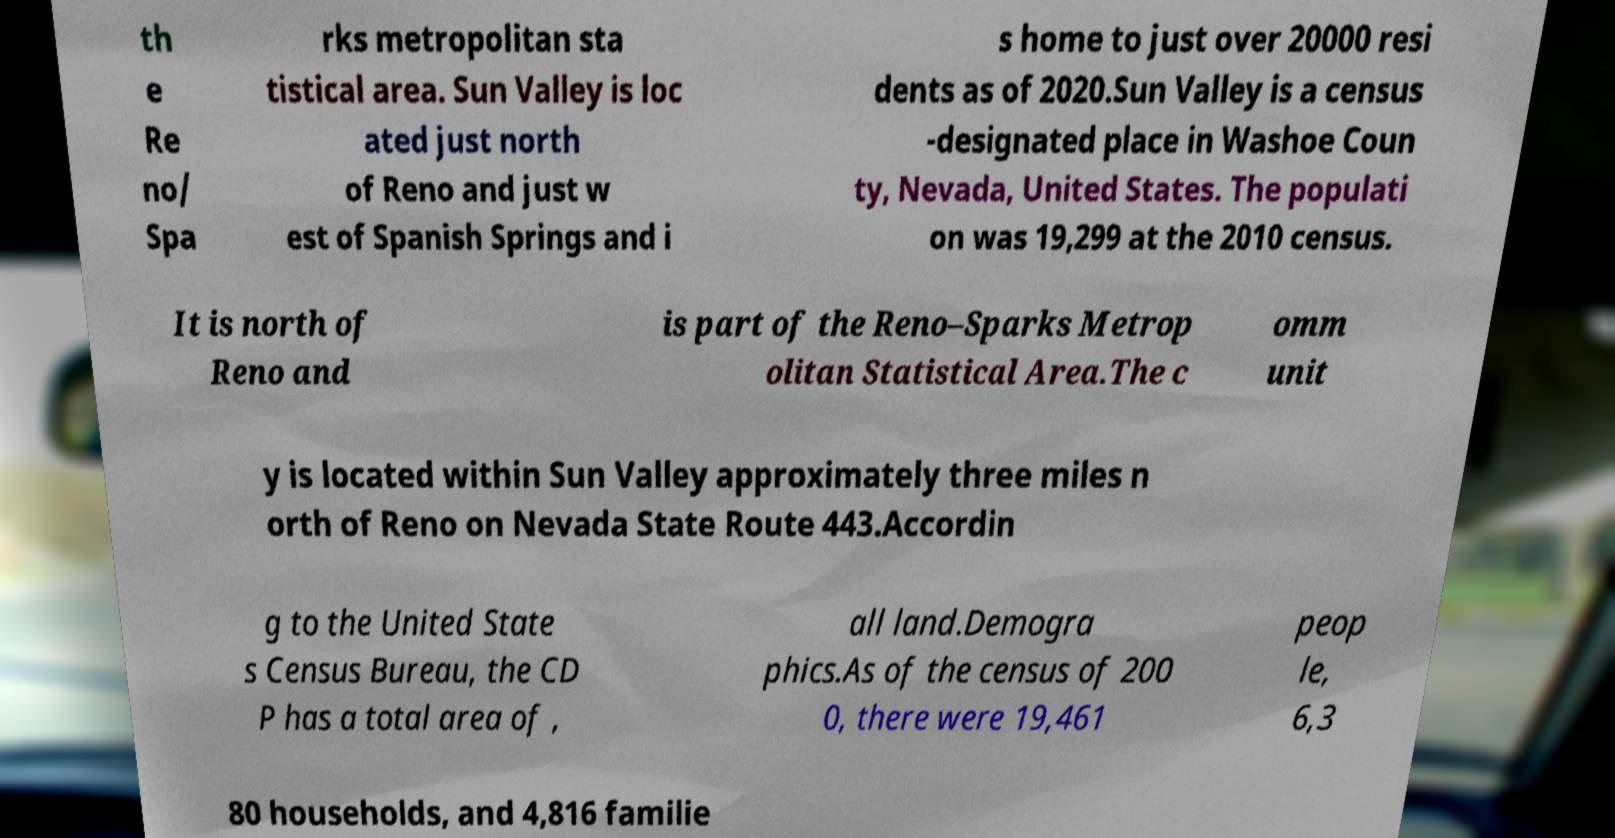Could you assist in decoding the text presented in this image and type it out clearly? th e Re no/ Spa rks metropolitan sta tistical area. Sun Valley is loc ated just north of Reno and just w est of Spanish Springs and i s home to just over 20000 resi dents as of 2020.Sun Valley is a census -designated place in Washoe Coun ty, Nevada, United States. The populati on was 19,299 at the 2010 census. It is north of Reno and is part of the Reno–Sparks Metrop olitan Statistical Area.The c omm unit y is located within Sun Valley approximately three miles n orth of Reno on Nevada State Route 443.Accordin g to the United State s Census Bureau, the CD P has a total area of , all land.Demogra phics.As of the census of 200 0, there were 19,461 peop le, 6,3 80 households, and 4,816 familie 